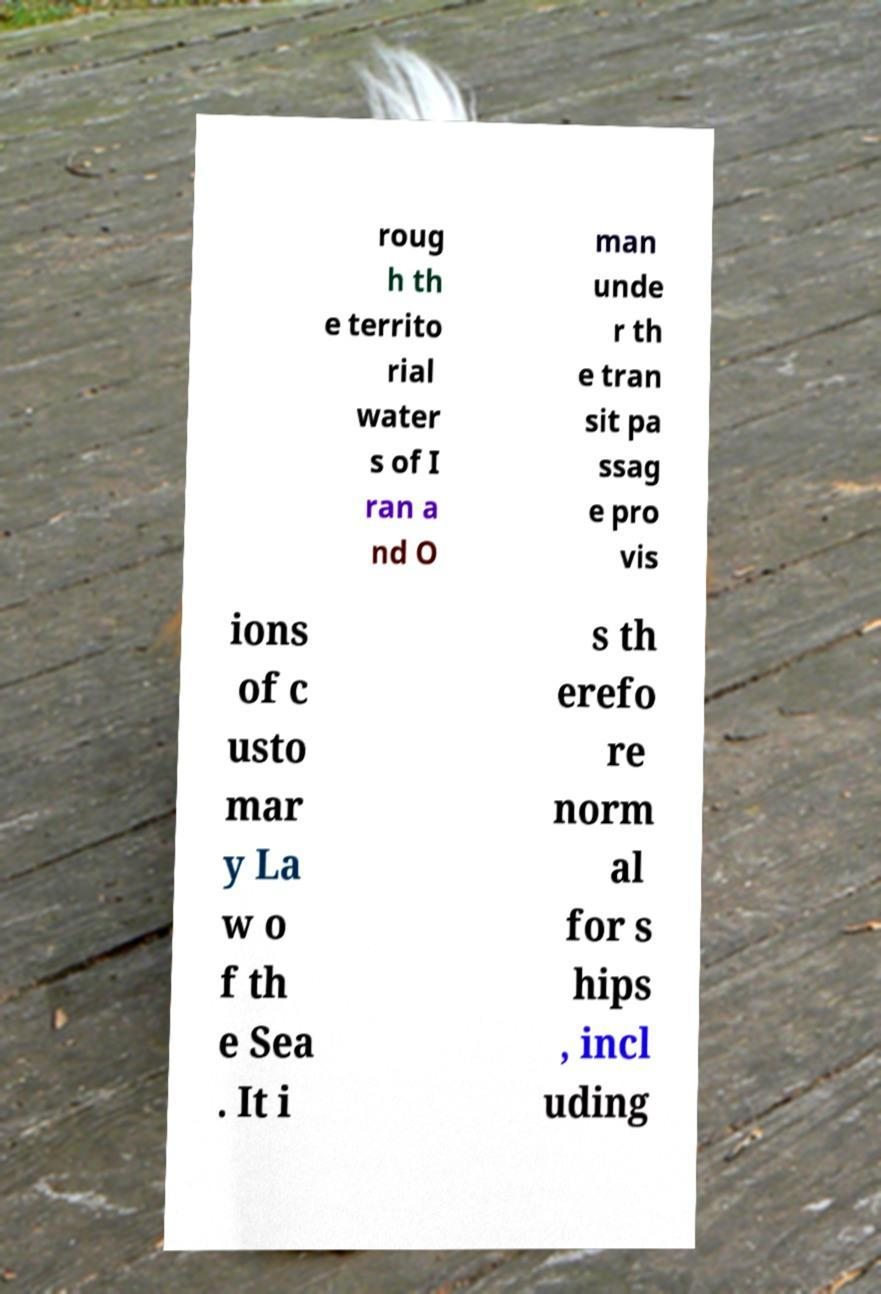I need the written content from this picture converted into text. Can you do that? roug h th e territo rial water s of I ran a nd O man unde r th e tran sit pa ssag e pro vis ions of c usto mar y La w o f th e Sea . It i s th erefo re norm al for s hips , incl uding 